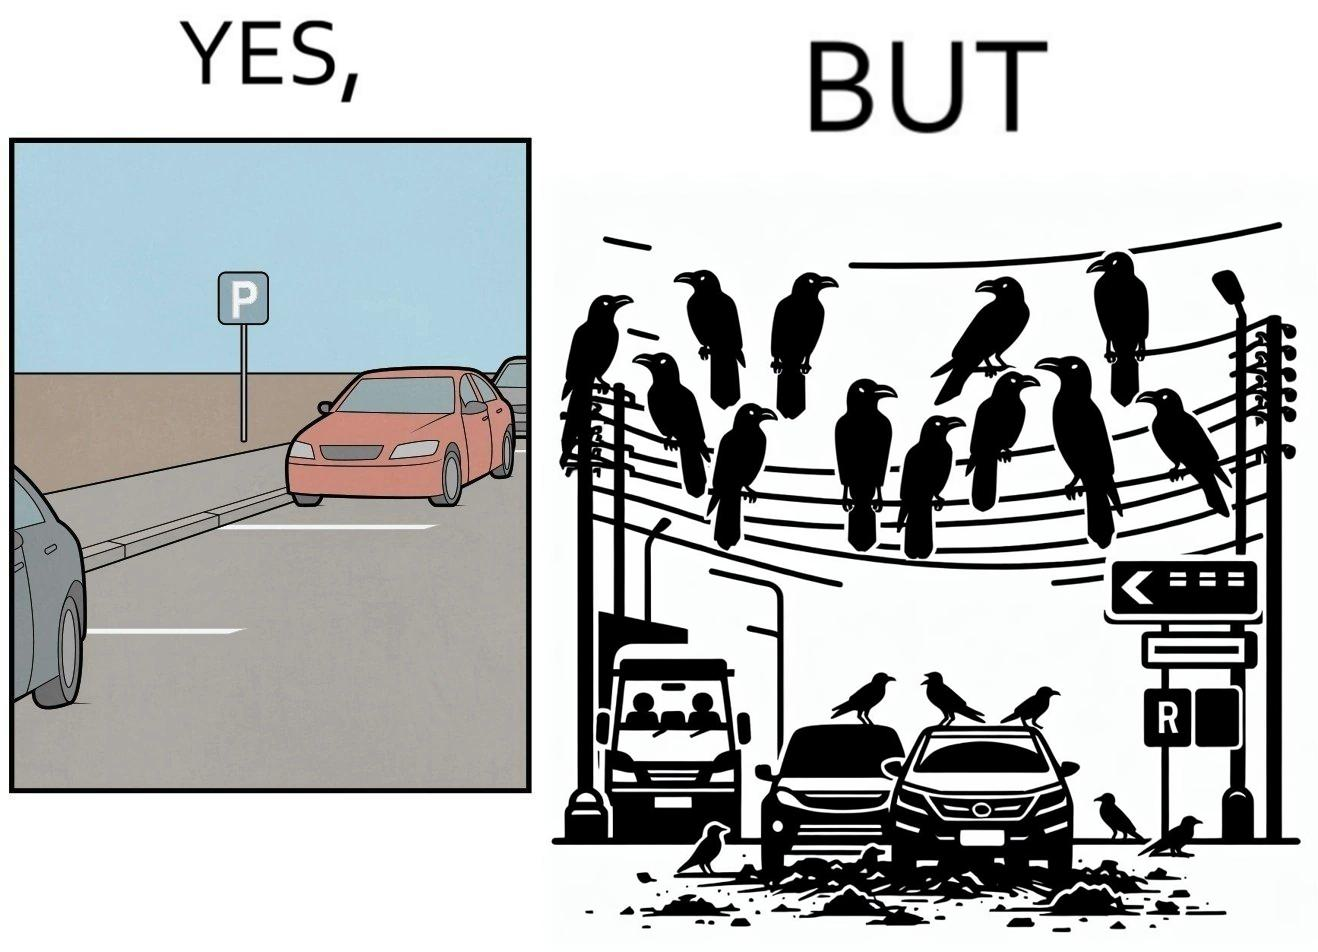Explain why this image is satirical. The image is ironical such that although there is a place for parking but that place is not suitable because if we place our car there then our car will become dirty from top due to crow beet. 